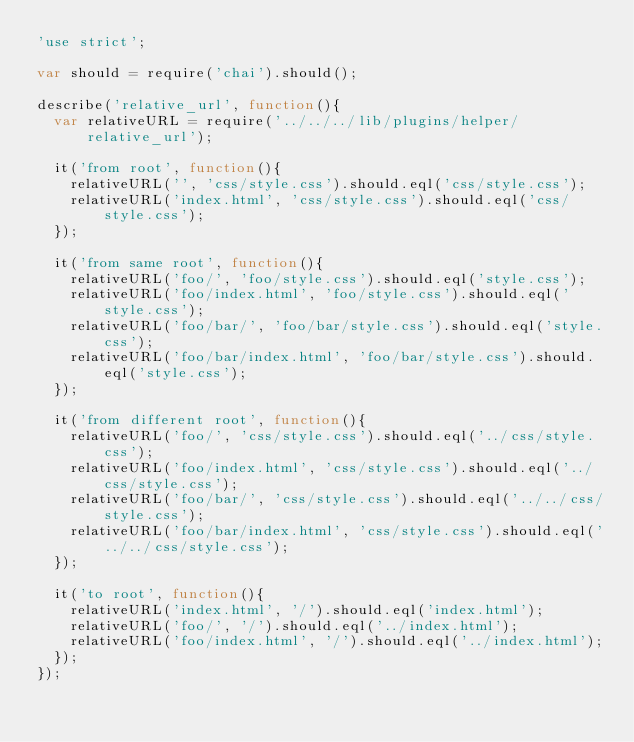Convert code to text. <code><loc_0><loc_0><loc_500><loc_500><_JavaScript_>'use strict';

var should = require('chai').should();

describe('relative_url', function(){
  var relativeURL = require('../../../lib/plugins/helper/relative_url');

  it('from root', function(){
    relativeURL('', 'css/style.css').should.eql('css/style.css');
    relativeURL('index.html', 'css/style.css').should.eql('css/style.css');
  });

  it('from same root', function(){
    relativeURL('foo/', 'foo/style.css').should.eql('style.css');
    relativeURL('foo/index.html', 'foo/style.css').should.eql('style.css');
    relativeURL('foo/bar/', 'foo/bar/style.css').should.eql('style.css');
    relativeURL('foo/bar/index.html', 'foo/bar/style.css').should.eql('style.css');
  });

  it('from different root', function(){
    relativeURL('foo/', 'css/style.css').should.eql('../css/style.css');
    relativeURL('foo/index.html', 'css/style.css').should.eql('../css/style.css');
    relativeURL('foo/bar/', 'css/style.css').should.eql('../../css/style.css');
    relativeURL('foo/bar/index.html', 'css/style.css').should.eql('../../css/style.css');
  });

  it('to root', function(){
    relativeURL('index.html', '/').should.eql('index.html');
    relativeURL('foo/', '/').should.eql('../index.html');
    relativeURL('foo/index.html', '/').should.eql('../index.html');
  });
});</code> 